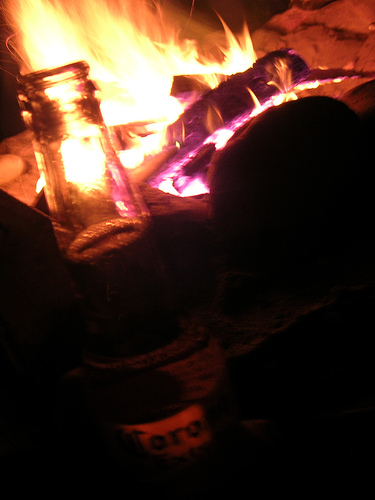<image>
Is there a fire behind the bottle? Yes. From this viewpoint, the fire is positioned behind the bottle, with the bottle partially or fully occluding the fire. 